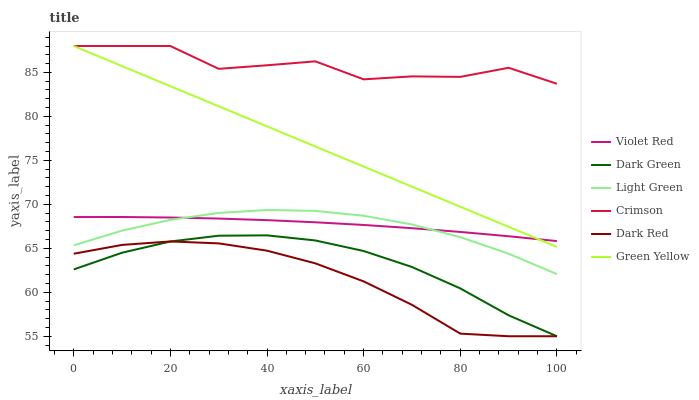Does Dark Red have the minimum area under the curve?
Answer yes or no. Yes. Does Crimson have the maximum area under the curve?
Answer yes or no. Yes. Does Light Green have the minimum area under the curve?
Answer yes or no. No. Does Light Green have the maximum area under the curve?
Answer yes or no. No. Is Green Yellow the smoothest?
Answer yes or no. Yes. Is Crimson the roughest?
Answer yes or no. Yes. Is Dark Red the smoothest?
Answer yes or no. No. Is Dark Red the roughest?
Answer yes or no. No. Does Dark Red have the lowest value?
Answer yes or no. Yes. Does Light Green have the lowest value?
Answer yes or no. No. Does Green Yellow have the highest value?
Answer yes or no. Yes. Does Light Green have the highest value?
Answer yes or no. No. Is Light Green less than Crimson?
Answer yes or no. Yes. Is Green Yellow greater than Dark Green?
Answer yes or no. Yes. Does Dark Red intersect Dark Green?
Answer yes or no. Yes. Is Dark Red less than Dark Green?
Answer yes or no. No. Is Dark Red greater than Dark Green?
Answer yes or no. No. Does Light Green intersect Crimson?
Answer yes or no. No. 